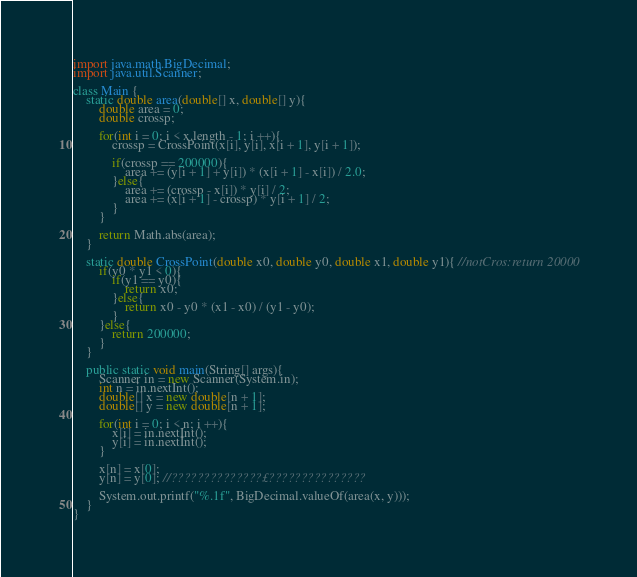Convert code to text. <code><loc_0><loc_0><loc_500><loc_500><_Java_>import java.math.BigDecimal;
import java.util.Scanner;

class Main {
	static double area(double[] x, double[] y){
		double area = 0;
		double crossp;
		
		for(int i = 0; i < x.length - 1; i ++){
			crossp = CrossPoint(x[i], y[i], x[i + 1], y[i + 1]);
			
			if(crossp == 200000){
				area += (y[i + 1] + y[i]) * (x[i + 1] - x[i]) / 2.0;
			}else{
				area += (crossp - x[i]) * y[i] / 2;
				area += (x[i + 1] - crossp) * y[i + 1] / 2;
			}
		}
		
		return Math.abs(area);
	}
	
	static double CrossPoint(double x0, double y0, double x1, double y1){ //notCros:return 20000
		if(y0 * y1 < 0){
			if(y1 == y0){
				return x0;
			}else{
				return x0 - y0 * (x1 - x0) / (y1 - y0);
			}
		}else{
			return 200000;
		}
	}
	
    public static void main(String[] args){
    	Scanner in = new Scanner(System.in);
    	int n = in.nextInt();
    	double[] x = new double[n + 1];
    	double[] y = new double[n + 1];
    	
    	for(int i = 0; i < n; i ++){
    		x[i] = in.nextInt();
    		y[i] = in.nextInt();
    	}

		x[n] = x[0];
		y[n] = y[0]; //??????????????£???????????????
    	
    	System.out.printf("%.1f", BigDecimal.valueOf(area(x, y)));
	}
}</code> 